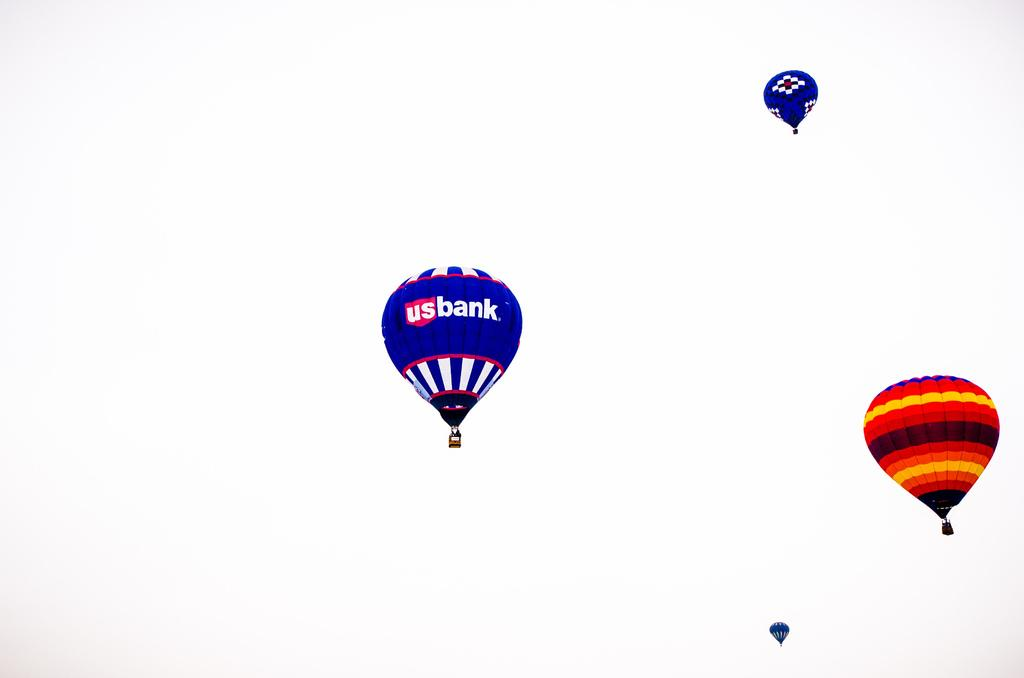What is the main subject of the image? The main subject of the image is gas balloons. Where are the gas balloons located in the image? The gas balloons are in the middle of the air. What type of fruit is being held by the father in the image? There is no father or fruit present in the image; it only features gas balloons in the air. 